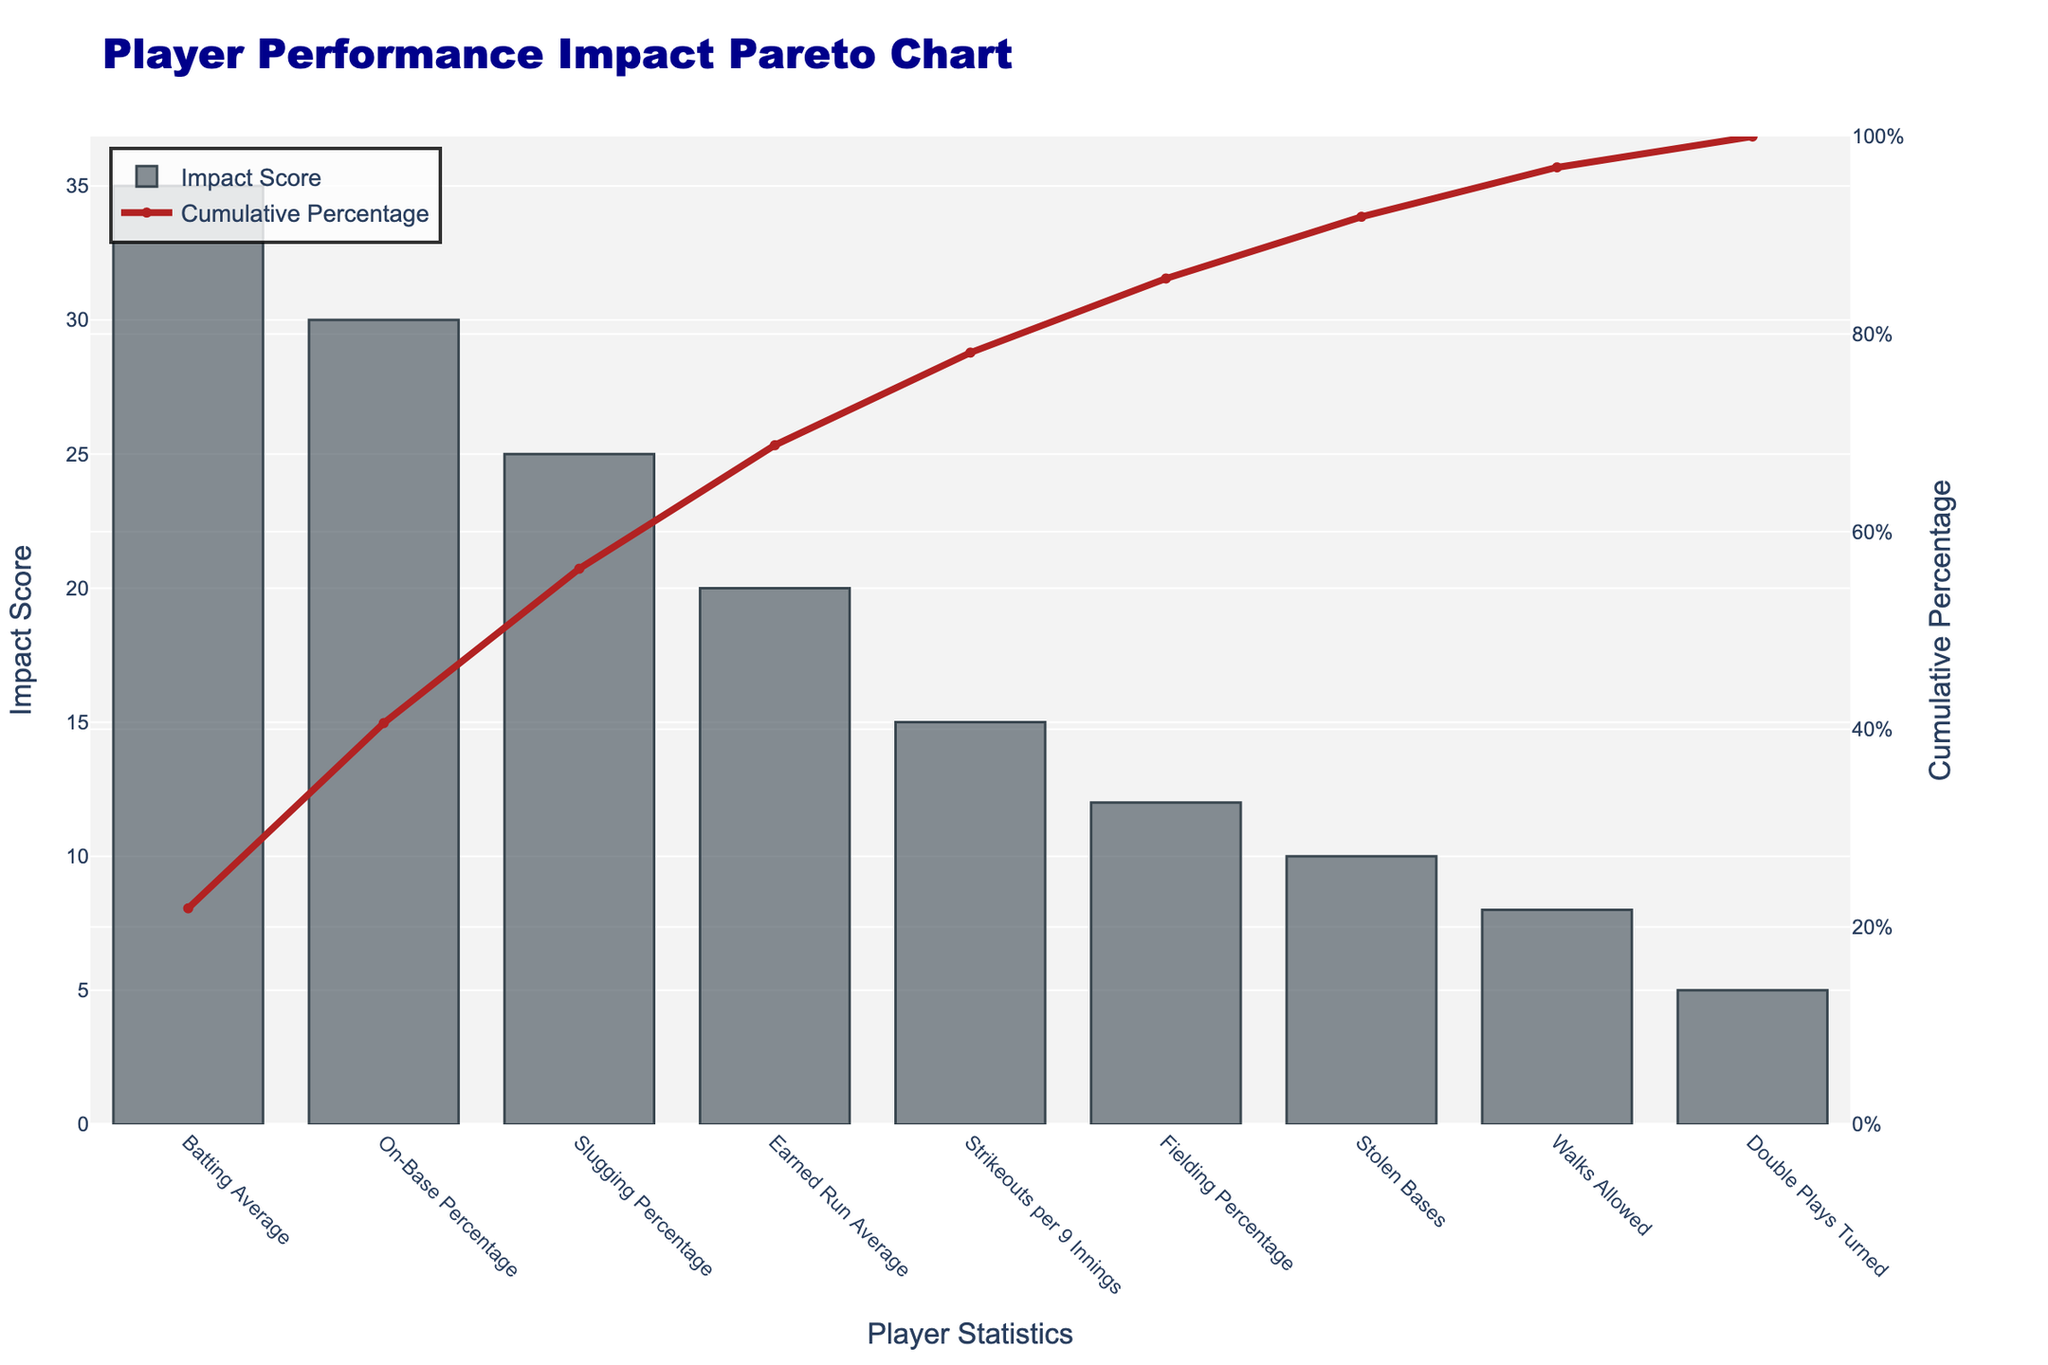What's the title of the chart? The title is usually displayed on the top of the chart and it provides a summary or description of what the chart is about. In this case, the title text is "Player Performance Impact Pareto Chart".
Answer: Player Performance Impact Pareto Chart Which player statistic has the highest impact score? The highest bar in a Pareto chart represents the player statistic with the highest impact score, labeled on the x-axis. In this case, "Batting Average" has the highest bar with an impact score of 35.
Answer: Batting Average What is the cumulative percentage when the earned run average is included? To find the cumulative percentage when "Earned Run Average" is included, locate the corresponding point on the line chart. The cumulative percentage for "Earned Run Average" is shown as 68.8%.
Answer: 68.8% How many player statistics are represented in this chart? Counting the number of bars (or x-axis labels) in the chart indicates the number of player statistics included. There are 9 player statistics represented.
Answer: 9 Which two player statistics, when combined, make up over 50% of the impact? To determine this, add the impact scores and cumulative percentages of statistics until the sum exceeds 50%. "Batting Average" (21.9%) and "On-Base Percentage" (40.6%) together exceed 50%, totaling 62.5%.
Answer: Batting Average and On-Base Percentage What is the impact score of fielding percentage? Locate the bar labeled "Fielding Percentage" and identify its height or corresponding value, which in this case is 12.
Answer: 12 What is the difference in impact scores between walks allowed and stolen bases? Subtract the impact score of "Walks Allowed" (8) from "Stolen Bases" (10). The difference is 10 - 8 = 2.
Answer: 2 Which player statistic has the lowest cumulative percentage before reaching 100%? The bar just before the final bar (100% marker) on the chart indicates the statistic with the lowest cumulative percentage before reaching 100%. "Walks Allowed" has a cumulative percentage of 96.9%.
Answer: Walks Allowed What is the cumulative percentage of the top three player statistics combined? Sum the cumulative percentages of the top three player statistics: 21.9% (Batting Average) + 40.6% (On-Base Percentage) + 56.3% (Slugging Percentage). 21.9 + 40.6 + 56.3 = 118.8%.
Answer: 118.8% How does the cumulative percentage help in understanding player performance? The cumulative percentage line in a Pareto chart helps by showing the collective impact of individual statistics. It highlights the most significant factors first, aiding in identifying key areas that contribute to overall performance.
Answer: It shows the collective impact of individual statistics 